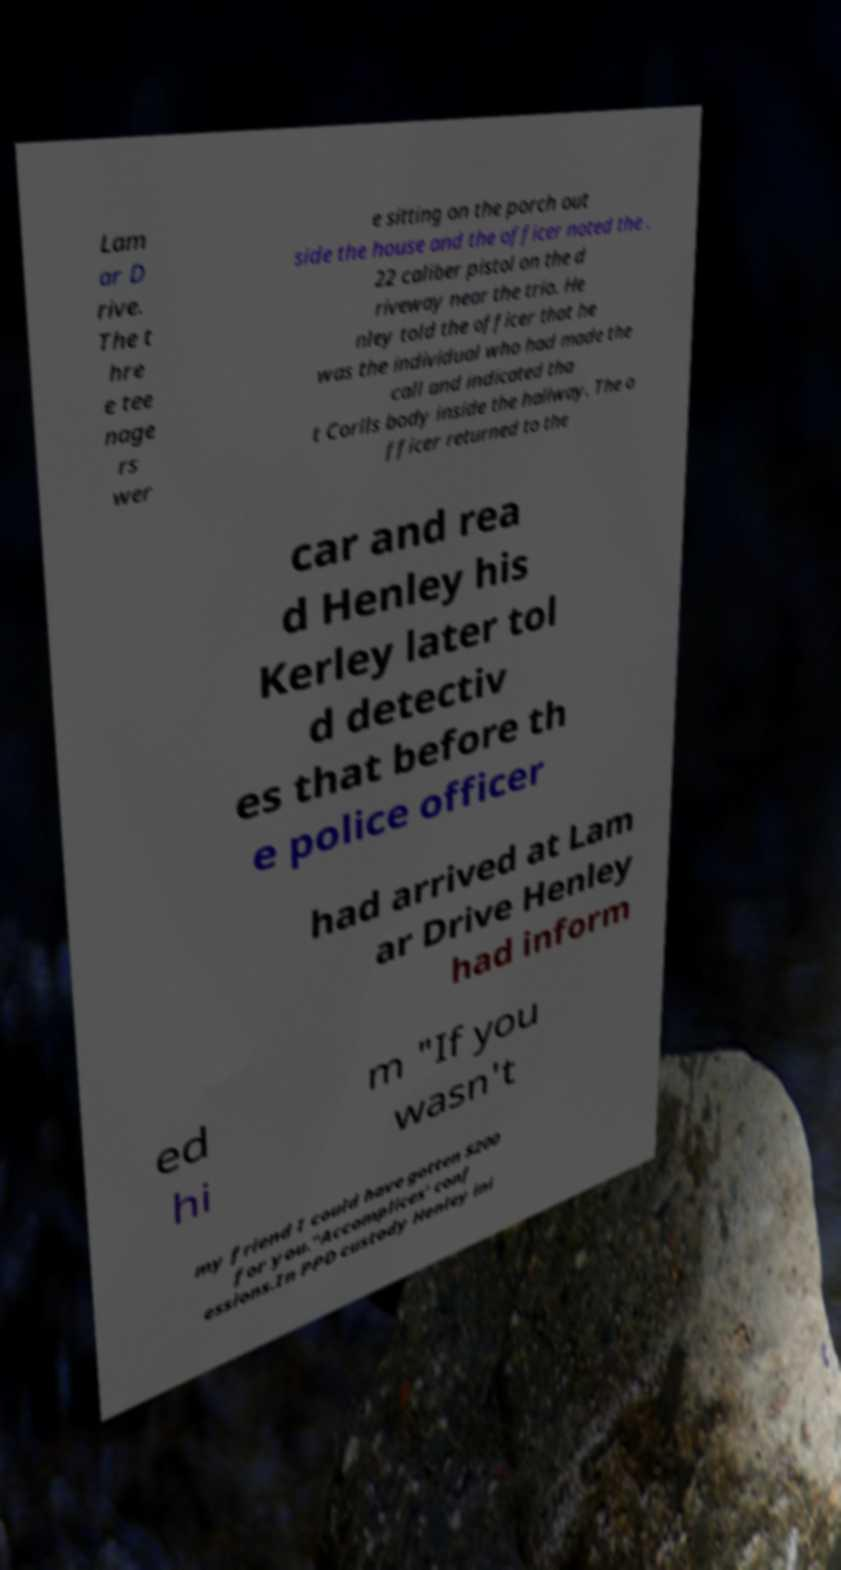Please read and relay the text visible in this image. What does it say? Lam ar D rive. The t hre e tee nage rs wer e sitting on the porch out side the house and the officer noted the . 22 caliber pistol on the d riveway near the trio. He nley told the officer that he was the individual who had made the call and indicated tha t Corlls body inside the hallway. The o fficer returned to the car and rea d Henley his Kerley later tol d detectiv es that before th e police officer had arrived at Lam ar Drive Henley had inform ed hi m "If you wasn't my friend I could have gotten $200 for you."Accomplices' conf essions.In PPD custody Henley ini 